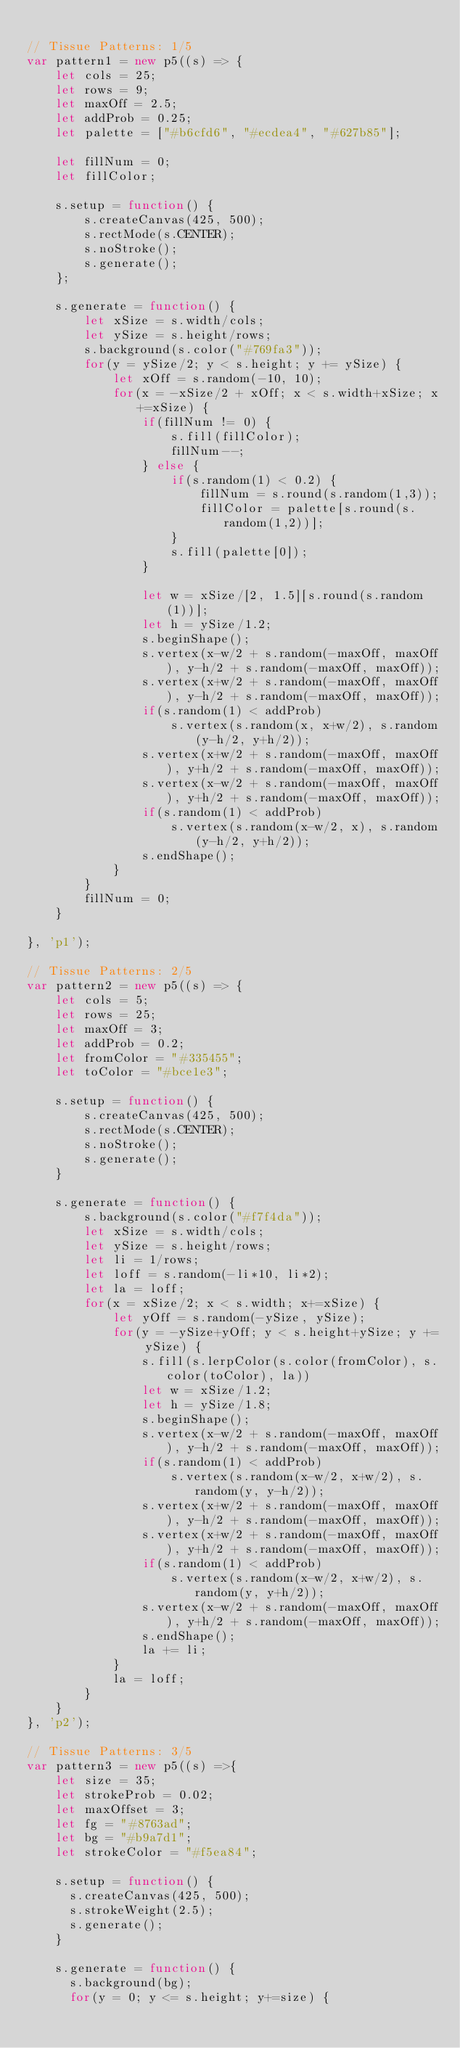<code> <loc_0><loc_0><loc_500><loc_500><_JavaScript_>
// Tissue Patterns: 1/5
var pattern1 = new p5((s) => {
    let cols = 25;
    let rows = 9;
    let maxOff = 2.5;
    let addProb = 0.25;
    let palette = ["#b6cfd6", "#ecdea4", "#627b85"];

    let fillNum = 0;
    let fillColor;

    s.setup = function() {
        s.createCanvas(425, 500);
        s.rectMode(s.CENTER);
        s.noStroke();
        s.generate();
    };

    s.generate = function() {
        let xSize = s.width/cols;
        let ySize = s.height/rows;
        s.background(s.color("#769fa3"));
        for(y = ySize/2; y < s.height; y += ySize) {
            let xOff = s.random(-10, 10);
            for(x = -xSize/2 + xOff; x < s.width+xSize; x+=xSize) {
                if(fillNum != 0) {
                    s.fill(fillColor);
                    fillNum--;
                } else {
                    if(s.random(1) < 0.2) {
                        fillNum = s.round(s.random(1,3));
                        fillColor = palette[s.round(s.random(1,2))];
                    }
                    s.fill(palette[0]);
                }
                
                let w = xSize/[2, 1.5][s.round(s.random(1))];
                let h = ySize/1.2;
                s.beginShape();
                s.vertex(x-w/2 + s.random(-maxOff, maxOff), y-h/2 + s.random(-maxOff, maxOff));
                s.vertex(x+w/2 + s.random(-maxOff, maxOff), y-h/2 + s.random(-maxOff, maxOff));
                if(s.random(1) < addProb)
                    s.vertex(s.random(x, x+w/2), s.random(y-h/2, y+h/2));
                s.vertex(x+w/2 + s.random(-maxOff, maxOff), y+h/2 + s.random(-maxOff, maxOff));
                s.vertex(x-w/2 + s.random(-maxOff, maxOff), y+h/2 + s.random(-maxOff, maxOff));
                if(s.random(1) < addProb)
                    s.vertex(s.random(x-w/2, x), s.random(y-h/2, y+h/2));
                s.endShape();
            }
        }
        fillNum = 0;
    }

}, 'p1');

// Tissue Patterns: 2/5
var pattern2 = new p5((s) => {
    let cols = 5;
    let rows = 25;
    let maxOff = 3;
    let addProb = 0.2;
    let fromColor = "#335455";
    let toColor = "#bce1e3";
    
    s.setup = function() {
        s.createCanvas(425, 500);
        s.rectMode(s.CENTER);
        s.noStroke();
        s.generate();
    }
    
    s.generate = function() {
        s.background(s.color("#f7f4da"));
        let xSize = s.width/cols;
        let ySize = s.height/rows;
        let li = 1/rows;
        let loff = s.random(-li*10, li*2);
        let la = loff;
        for(x = xSize/2; x < s.width; x+=xSize) {
            let yOff = s.random(-ySize, ySize);
            for(y = -ySize+yOff; y < s.height+ySize; y += ySize) {
                s.fill(s.lerpColor(s.color(fromColor), s.color(toColor), la))
                let w = xSize/1.2;
                let h = ySize/1.8;
                s.beginShape();
                s.vertex(x-w/2 + s.random(-maxOff, maxOff), y-h/2 + s.random(-maxOff, maxOff));
                if(s.random(1) < addProb)
                    s.vertex(s.random(x-w/2, x+w/2), s.random(y, y-h/2));
                s.vertex(x+w/2 + s.random(-maxOff, maxOff), y-h/2 + s.random(-maxOff, maxOff));
                s.vertex(x+w/2 + s.random(-maxOff, maxOff), y+h/2 + s.random(-maxOff, maxOff));
                if(s.random(1) < addProb)
                    s.vertex(s.random(x-w/2, x+w/2), s.random(y, y+h/2));
                s.vertex(x-w/2 + s.random(-maxOff, maxOff), y+h/2 + s.random(-maxOff, maxOff));
                s.endShape();
                la += li;
            }
            la = loff;
        }
    }
}, 'p2');

// Tissue Patterns: 3/5
var pattern3 = new p5((s) =>{
    let size = 35;
    let strokeProb = 0.02;
    let maxOffset = 3;
    let fg = "#8763ad";
    let bg = "#b9a7d1";
    let strokeColor = "#f5ea84";
    
    s.setup = function() {
      s.createCanvas(425, 500);
      s.strokeWeight(2.5);
      s.generate();
    }

    s.generate = function() {
      s.background(bg);
      for(y = 0; y <= s.height; y+=size) {</code> 